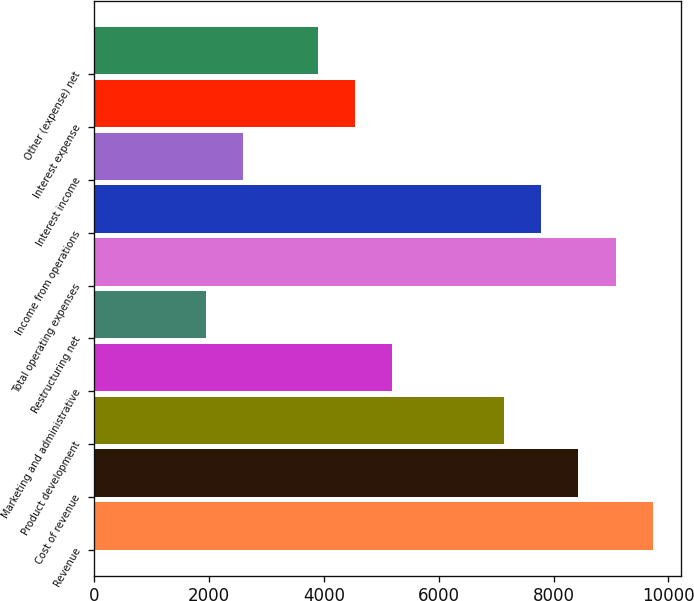Convert chart to OTSL. <chart><loc_0><loc_0><loc_500><loc_500><bar_chart><fcel>Revenue<fcel>Cost of revenue<fcel>Product development<fcel>Marketing and administrative<fcel>Restructuring net<fcel>Total operating expenses<fcel>Income from operations<fcel>Interest income<fcel>Interest expense<fcel>Other (expense) net<nl><fcel>9728.66<fcel>8431.6<fcel>7134.54<fcel>5188.95<fcel>1946.3<fcel>9080.13<fcel>7783.07<fcel>2594.83<fcel>4540.42<fcel>3891.89<nl></chart> 